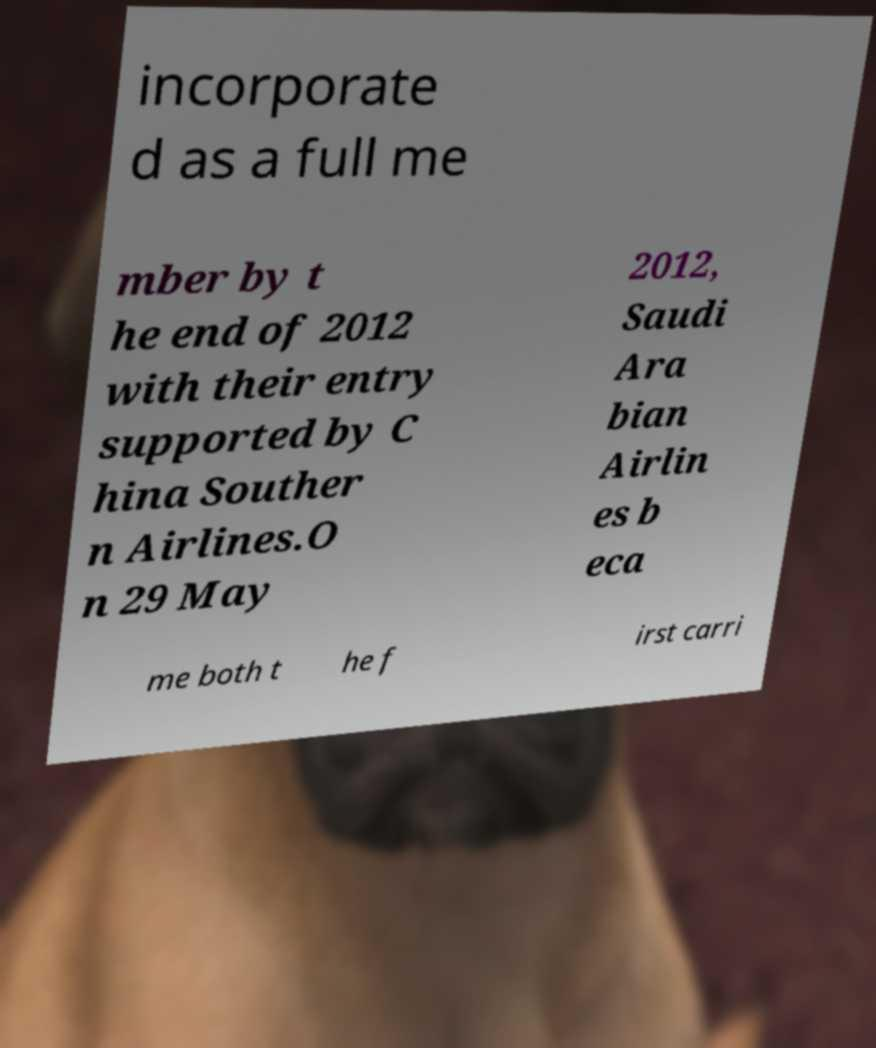What messages or text are displayed in this image? I need them in a readable, typed format. incorporate d as a full me mber by t he end of 2012 with their entry supported by C hina Souther n Airlines.O n 29 May 2012, Saudi Ara bian Airlin es b eca me both t he f irst carri 